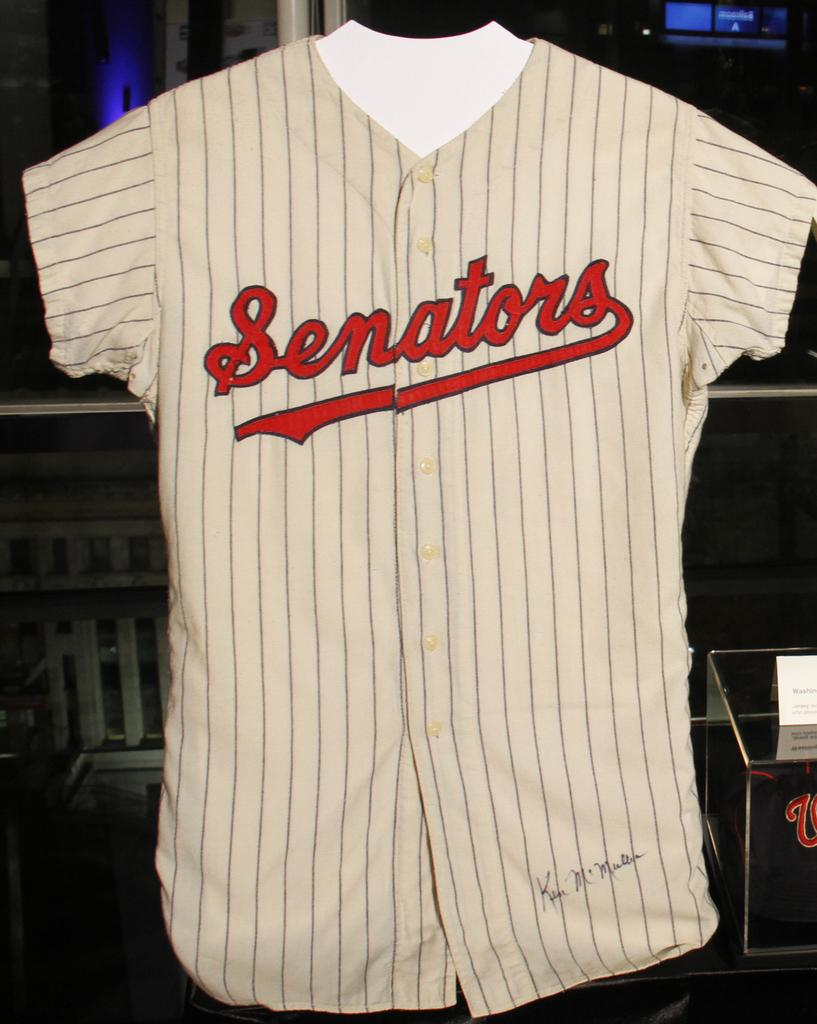Provide a one-sentence caption for the provided image. Baseball jersy that ha Senators across middle and signed by Ken McMullen. 